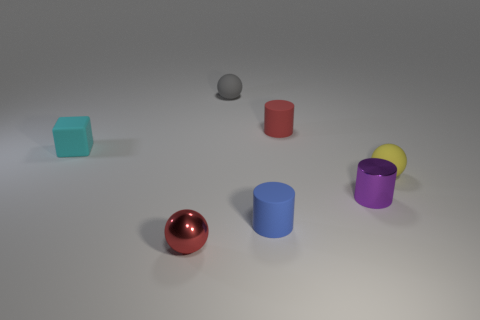Can you tell me about the lighting of this scene? Sure, the lighting in this scene appears to be soft and diffused, coming from an overhead source. It creates gentle shadows on the floor, indicating the light is not excessively harsh and provides even illumination to the objects. How does the lighting affect the colors of the objects? The soft lighting allows for the true colors of the objects to be seen without harsh reflections or deep shadows. It enhances the vividness of each object's color and allows for reflection details to be observed on the shinier surfaces. 